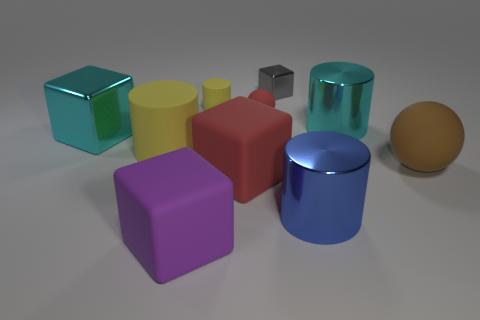Subtract all balls. How many objects are left? 8 Add 8 brown matte balls. How many brown matte balls are left? 9 Add 4 brown rubber spheres. How many brown rubber spheres exist? 5 Subtract 0 purple cylinders. How many objects are left? 10 Subtract all small red balls. Subtract all large purple objects. How many objects are left? 8 